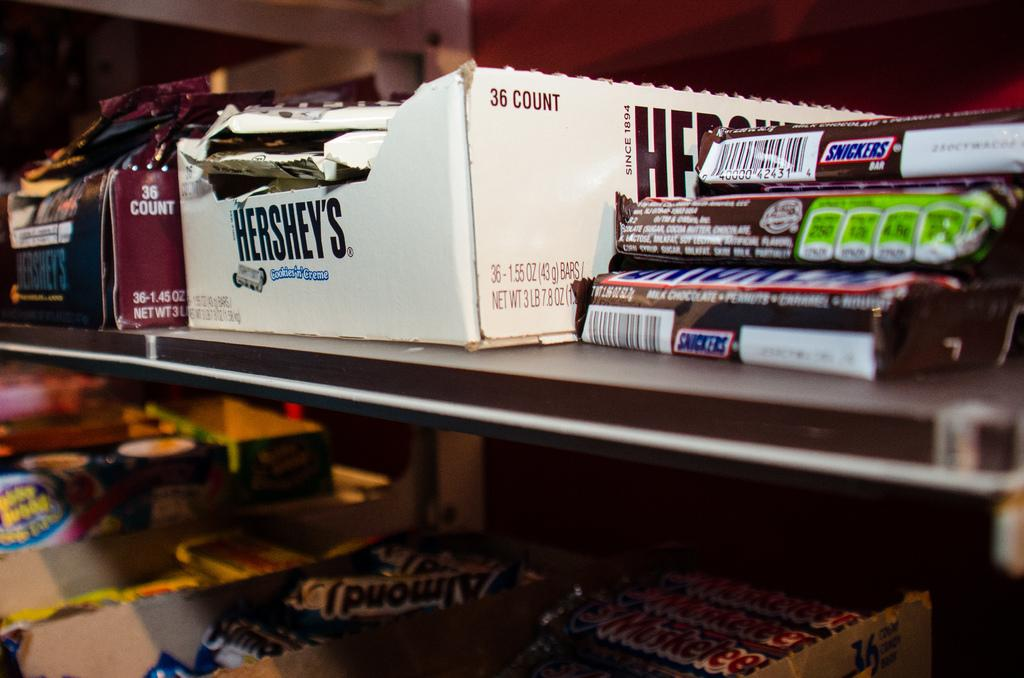Provide a one-sentence caption for the provided image. Boxes of candy including hersey's and snickers and almond joy. 